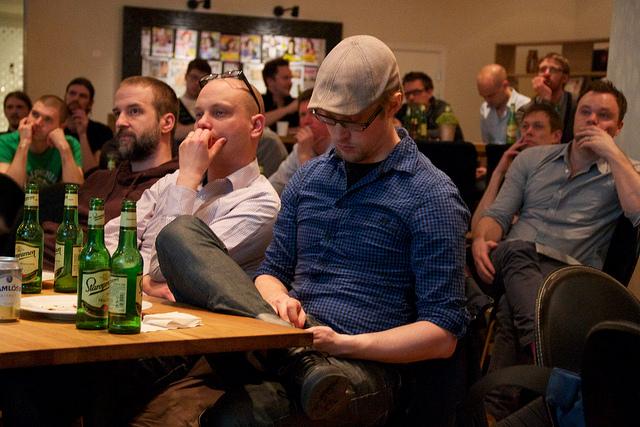What does the bald person have on their shirt?
Write a very short answer. Nothing. What color are these man's pants?
Keep it brief. Black. How many people are shown?
Concise answer only. 15. Do the people have microphones?
Write a very short answer. No. What pattern is the man's shirt?
Be succinct. Checkered. What is the man with hat doing?
Write a very short answer. Texting. What color hat is the man wearing?
Give a very brief answer. Gray. How many guys are in the image?
Write a very short answer. 14. What are the two men in the middle wearing?
Quick response, please. Shirts. How many men are sitting down?
Be succinct. 13. What are the  men drinking?
Quick response, please. Beer. How many men do you see with button down shirts?
Quick response, please. 4. What are the people wearing on their shirts?
Concise answer only. Nothing. Does everyone have a vest on?
Be succinct. No. What brand of soda is being drunk?
Write a very short answer. Sprite. Are all the chairs full?
Short answer required. Yes. Is there a Muslim in the room?
Give a very brief answer. No. Is everyone in the photo seated?
Short answer required. No. Is this casual attire?
Keep it brief. Yes. Are these people family?
Be succinct. No. What are the people doing?
Keep it brief. Sitting. 